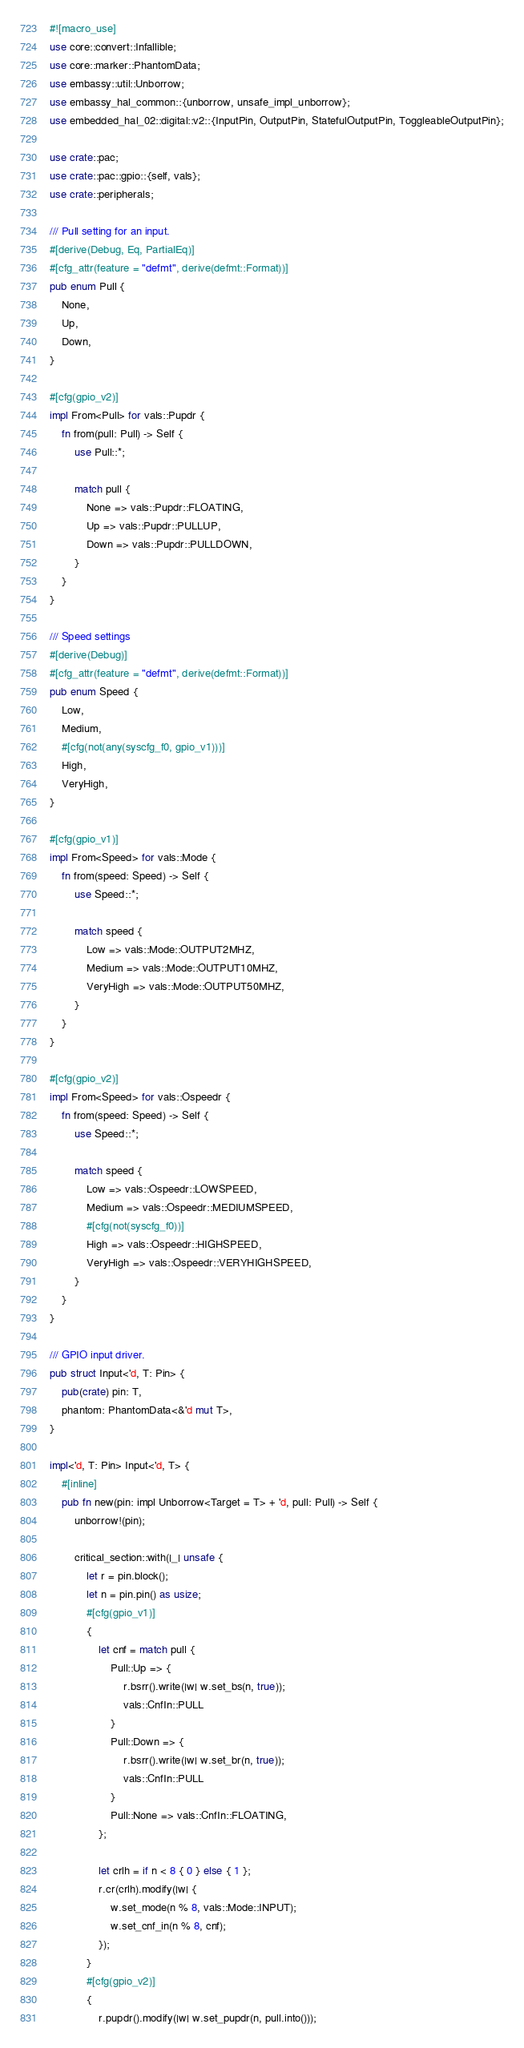Convert code to text. <code><loc_0><loc_0><loc_500><loc_500><_Rust_>#![macro_use]
use core::convert::Infallible;
use core::marker::PhantomData;
use embassy::util::Unborrow;
use embassy_hal_common::{unborrow, unsafe_impl_unborrow};
use embedded_hal_02::digital::v2::{InputPin, OutputPin, StatefulOutputPin, ToggleableOutputPin};

use crate::pac;
use crate::pac::gpio::{self, vals};
use crate::peripherals;

/// Pull setting for an input.
#[derive(Debug, Eq, PartialEq)]
#[cfg_attr(feature = "defmt", derive(defmt::Format))]
pub enum Pull {
    None,
    Up,
    Down,
}

#[cfg(gpio_v2)]
impl From<Pull> for vals::Pupdr {
    fn from(pull: Pull) -> Self {
        use Pull::*;

        match pull {
            None => vals::Pupdr::FLOATING,
            Up => vals::Pupdr::PULLUP,
            Down => vals::Pupdr::PULLDOWN,
        }
    }
}

/// Speed settings
#[derive(Debug)]
#[cfg_attr(feature = "defmt", derive(defmt::Format))]
pub enum Speed {
    Low,
    Medium,
    #[cfg(not(any(syscfg_f0, gpio_v1)))]
    High,
    VeryHigh,
}

#[cfg(gpio_v1)]
impl From<Speed> for vals::Mode {
    fn from(speed: Speed) -> Self {
        use Speed::*;

        match speed {
            Low => vals::Mode::OUTPUT2MHZ,
            Medium => vals::Mode::OUTPUT10MHZ,
            VeryHigh => vals::Mode::OUTPUT50MHZ,
        }
    }
}

#[cfg(gpio_v2)]
impl From<Speed> for vals::Ospeedr {
    fn from(speed: Speed) -> Self {
        use Speed::*;

        match speed {
            Low => vals::Ospeedr::LOWSPEED,
            Medium => vals::Ospeedr::MEDIUMSPEED,
            #[cfg(not(syscfg_f0))]
            High => vals::Ospeedr::HIGHSPEED,
            VeryHigh => vals::Ospeedr::VERYHIGHSPEED,
        }
    }
}

/// GPIO input driver.
pub struct Input<'d, T: Pin> {
    pub(crate) pin: T,
    phantom: PhantomData<&'d mut T>,
}

impl<'d, T: Pin> Input<'d, T> {
    #[inline]
    pub fn new(pin: impl Unborrow<Target = T> + 'd, pull: Pull) -> Self {
        unborrow!(pin);

        critical_section::with(|_| unsafe {
            let r = pin.block();
            let n = pin.pin() as usize;
            #[cfg(gpio_v1)]
            {
                let cnf = match pull {
                    Pull::Up => {
                        r.bsrr().write(|w| w.set_bs(n, true));
                        vals::CnfIn::PULL
                    }
                    Pull::Down => {
                        r.bsrr().write(|w| w.set_br(n, true));
                        vals::CnfIn::PULL
                    }
                    Pull::None => vals::CnfIn::FLOATING,
                };

                let crlh = if n < 8 { 0 } else { 1 };
                r.cr(crlh).modify(|w| {
                    w.set_mode(n % 8, vals::Mode::INPUT);
                    w.set_cnf_in(n % 8, cnf);
                });
            }
            #[cfg(gpio_v2)]
            {
                r.pupdr().modify(|w| w.set_pupdr(n, pull.into()));</code> 